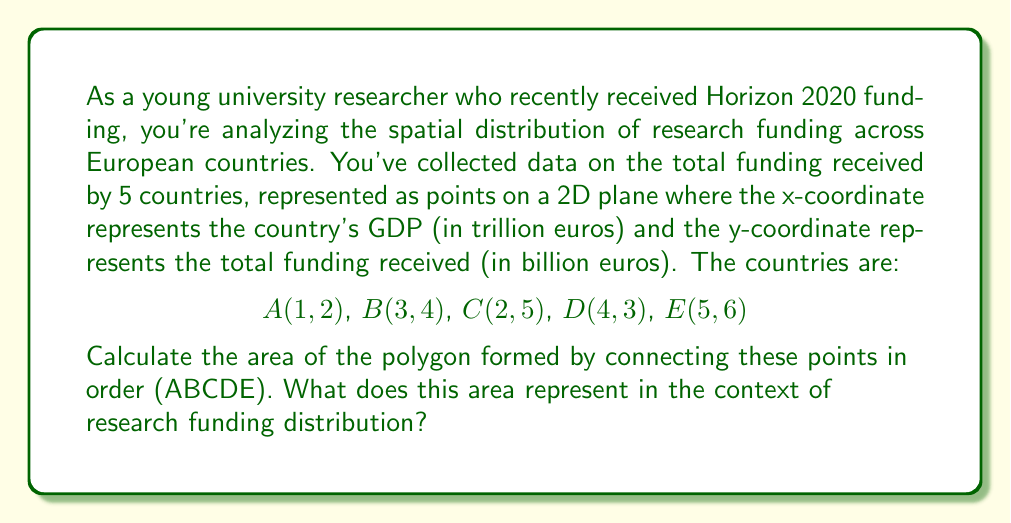Show me your answer to this math problem. To solve this problem, we'll use the Shoelace formula (also known as the surveyor's formula) to calculate the area of an irregular polygon given its vertices.

The Shoelace formula is:

$$Area = \frac{1}{2}|\sum_{i=1}^{n-1} (x_iy_{i+1} + x_ny_1) - \sum_{i=1}^{n-1} (y_ix_{i+1} + y_nx_1)|$$

Where $(x_i, y_i)$ are the coordinates of the $i$-th vertex.

Let's apply this formula to our points:

1) First, calculate the sum of the products of x-coordinates with the next y-coordinate:
   $$(1 \cdot 4) + (3 \cdot 5) + (2 \cdot 3) + (4 \cdot 6) + (5 \cdot 2) = 4 + 15 + 6 + 24 + 10 = 59$$

2) Then, calculate the sum of the products of y-coordinates with the next x-coordinate:
   $$(2 \cdot 3) + (4 \cdot 2) + (5 \cdot 4) + (3 \cdot 5) + (6 \cdot 1) = 6 + 8 + 20 + 15 + 6 = 55$$

3) Subtract the second sum from the first:
   $$59 - 55 = 4$$

4) Take the absolute value and divide by 2:
   $$\frac{|4|}{2} = 2$$

Therefore, the area of the polygon is 2 square units.

In the context of research funding distribution, this area represents the spread or dispersion of funding across the GDP spectrum. A larger area would indicate a more uneven distribution of funding relative to GDP, while a smaller area would suggest a more uniform distribution. The shape of the polygon can also provide insights into funding patterns across countries with different economic sizes.
Answer: The area of the polygon is 2 square units. This represents the spread of research funding distribution across the five European countries relative to their GDPs. 